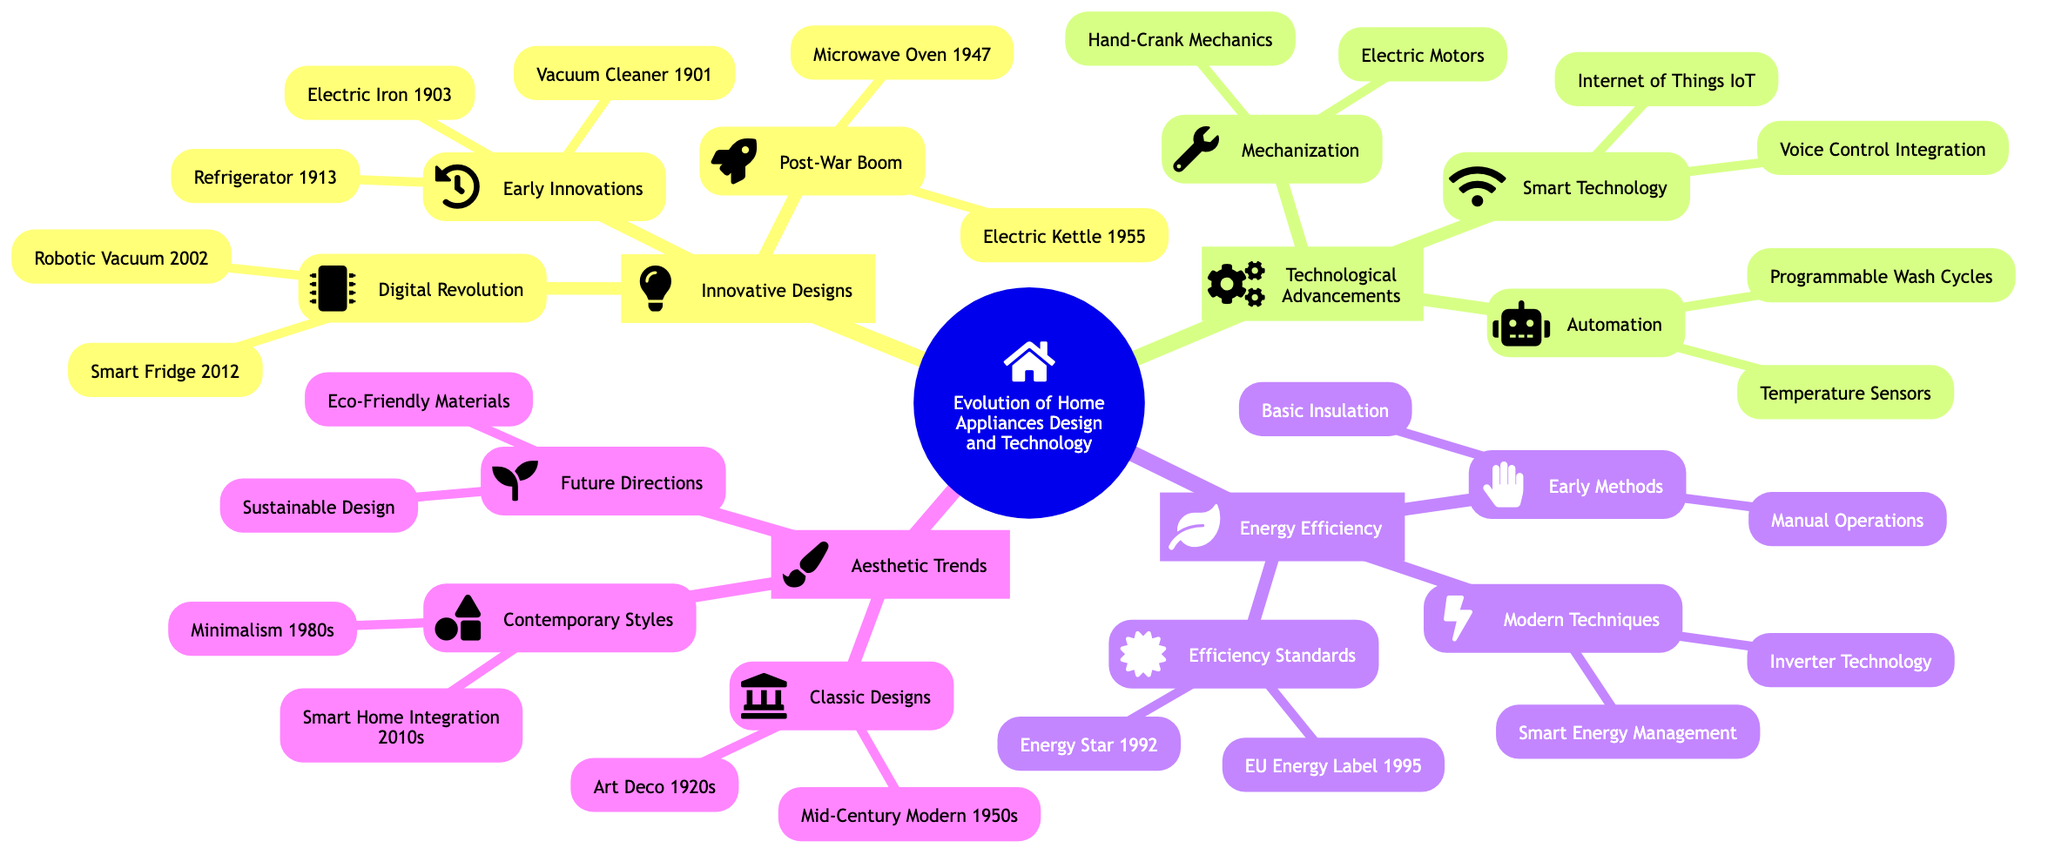What was the first appliance listed under Early Innovations? The diagram indicates the first appliance listed under Early Innovations is the Electric Iron from 1903. This can be found at the branch labeled "Early Innovations," which lists the Electric Iron as the first element.
Answer: Electric Iron (1903) How many sub-branches are under Innovative Designs? In the diagram, there are three sub-branches under Innovative Designs: Early Innovations, Post-War Boom, and Digital Revolution. Each sub-branch contains elements pertaining to different periods of innovation in home appliance design. Summing them gives a total of three.
Answer: 3 Which year was the Energy Star standard introduced? According to the diagram under the Efficiency Standards sub-branch, the Energy Star standard was introduced in 1992. This specific date is clearly labeled in the section dealing with energy efficiency.
Answer: 1992 What technology is associated with the concept of Smart Technology? The diagram under the Smart Technology sub-branch indicates that the Internet of Things (IoT) and Voice Control Integration are associated with this concept. I can cross-reference with the 'Technological Advancements' section which specifies Smart Technology.
Answer: Internet of Things (IoT) What do the Modern Techniques focus on under Energy Efficiency? The Modern Techniques sub-branch under Energy Efficiency specifically emphasizes Inverter Technology and Smart Energy Management. I can identify these elements in the respective section named 'Modern Techniques.'
Answer: Inverter Technology How many elements are listed under Post-War Boom? The diagram shows that there are two elements listed under the Post-War Boom: Microwave Oven (1947) and Electric Kettle (1955). Counting these gives a total of two elements.
Answer: 2 Which era is highlighted under Classic Designs? The Classic Designs sub-branch mentions two specific eras: Art Deco from the 1920s and Mid-Century Modern from the 1950s. This can be verified by looking at the Classic Designs section of Aesthetic Trends.
Answer: 1920s How is the relationship between Mechanization and Automation depicted? The diagram shows Mechanization as one of the branches leading to Automation, indicating a progression in technology. Mechanization includes elements like Hand-Crank Mechanics and Electric Motors, while Automation involves more advanced technologies like Programmable Wash Cycles and Temperature Sensors. Thus, the relationship is one of advancement from basic mechanics to automation technologies.
Answer: Advancement What future trends are mentioned under Future Directions? The Future Directions sub-branch highlights two specific trends: Eco-Friendly Materials and Sustainable Design. These are explicitly noted in the Future Directions section of Aesthetic Trends in the diagram.
Answer: Eco-Friendly Materials 